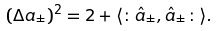<formula> <loc_0><loc_0><loc_500><loc_500>( \Delta a _ { \pm } ) ^ { 2 } = 2 + \langle \colon \hat { a } _ { \pm } , \hat { a } _ { \pm } \colon \rangle .</formula> 